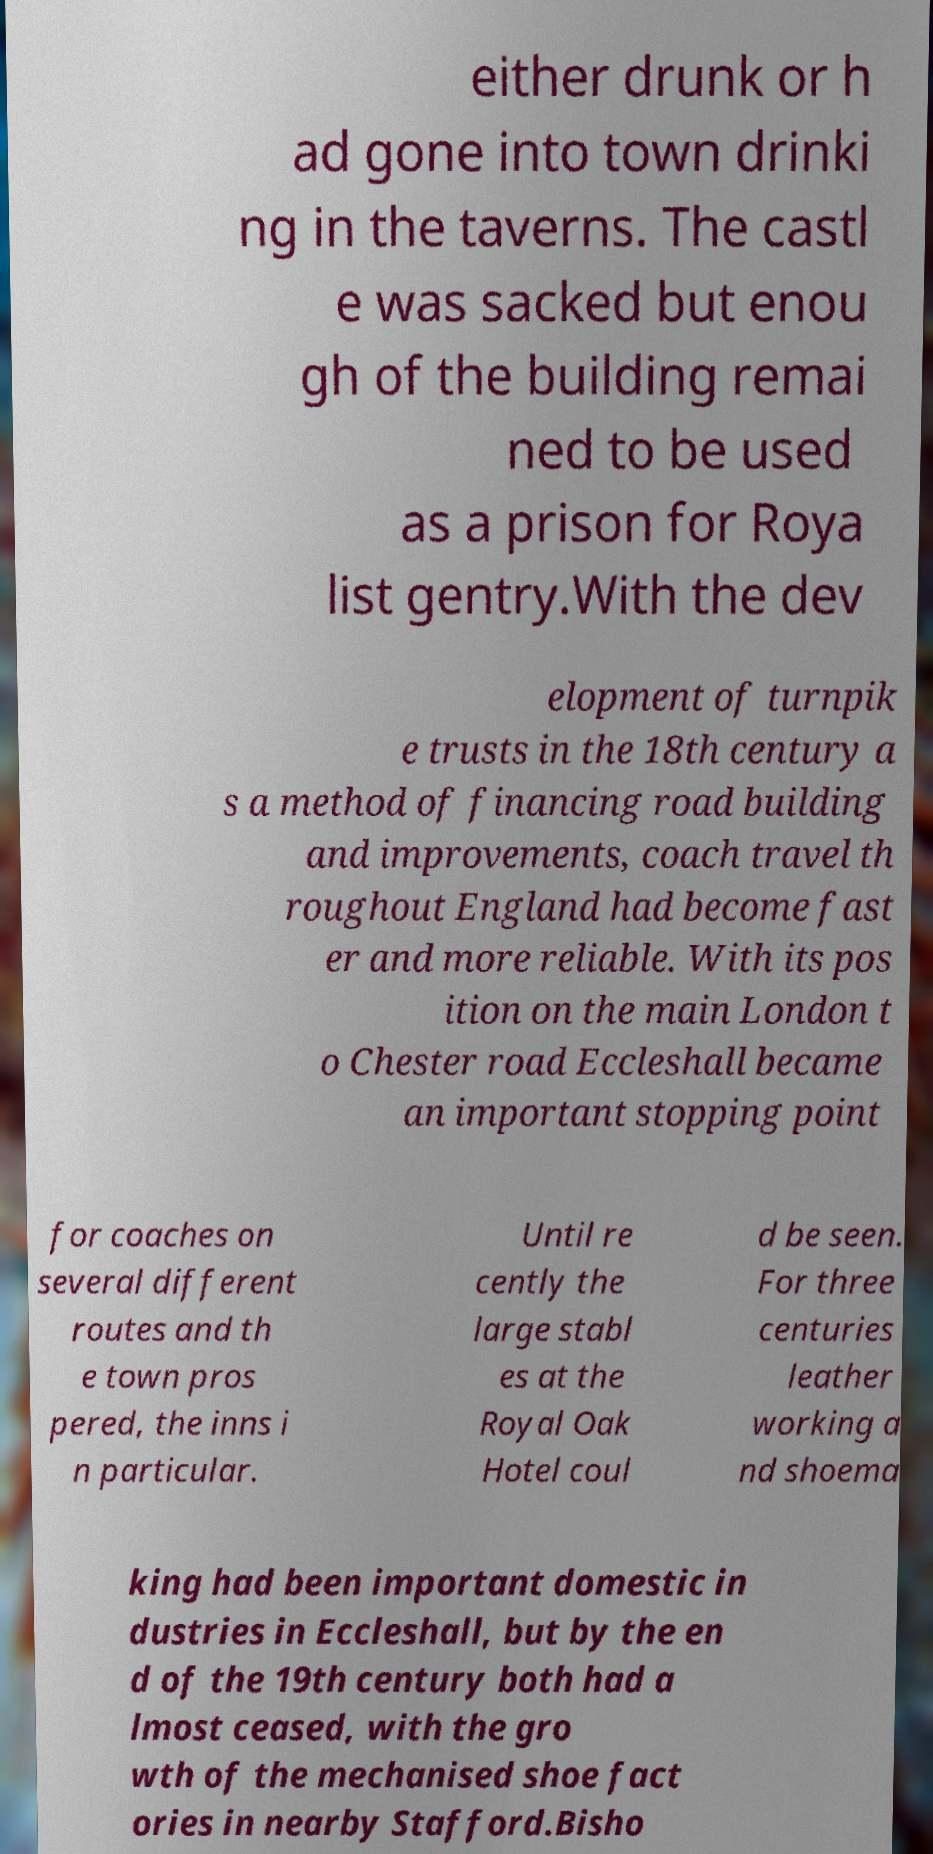Can you read and provide the text displayed in the image?This photo seems to have some interesting text. Can you extract and type it out for me? either drunk or h ad gone into town drinki ng in the taverns. The castl e was sacked but enou gh of the building remai ned to be used as a prison for Roya list gentry.With the dev elopment of turnpik e trusts in the 18th century a s a method of financing road building and improvements, coach travel th roughout England had become fast er and more reliable. With its pos ition on the main London t o Chester road Eccleshall became an important stopping point for coaches on several different routes and th e town pros pered, the inns i n particular. Until re cently the large stabl es at the Royal Oak Hotel coul d be seen. For three centuries leather working a nd shoema king had been important domestic in dustries in Eccleshall, but by the en d of the 19th century both had a lmost ceased, with the gro wth of the mechanised shoe fact ories in nearby Stafford.Bisho 